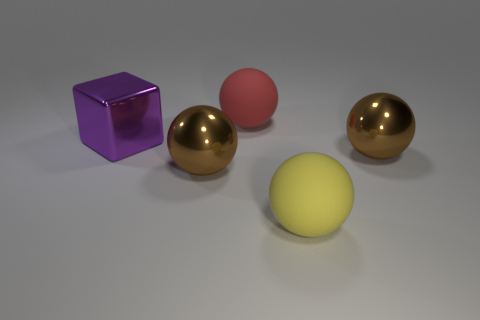What shape is the red rubber thing that is the same size as the yellow matte sphere?
Make the answer very short. Sphere. Do the large block and the metal ball left of the yellow matte thing have the same color?
Ensure brevity in your answer.  No. There is a large brown metal ball left of the big yellow thing; what number of brown balls are to the left of it?
Give a very brief answer. 0. There is a thing that is on the left side of the yellow ball and in front of the shiny block; what size is it?
Ensure brevity in your answer.  Large. Are there any yellow objects of the same size as the purple cube?
Keep it short and to the point. Yes. Is the number of big brown metal balls that are on the right side of the yellow object greater than the number of brown balls behind the large purple shiny object?
Your answer should be very brief. Yes. Are the large red sphere and the large yellow thing that is in front of the red object made of the same material?
Ensure brevity in your answer.  Yes. What number of big metallic spheres are in front of the big brown shiny object right of the matte ball in front of the purple block?
Offer a terse response. 1. There is a red matte object; is it the same shape as the big brown shiny thing to the left of the large yellow rubber sphere?
Provide a succinct answer. Yes. The large metallic object that is both on the right side of the big purple thing and left of the yellow sphere is what color?
Your response must be concise. Brown. 